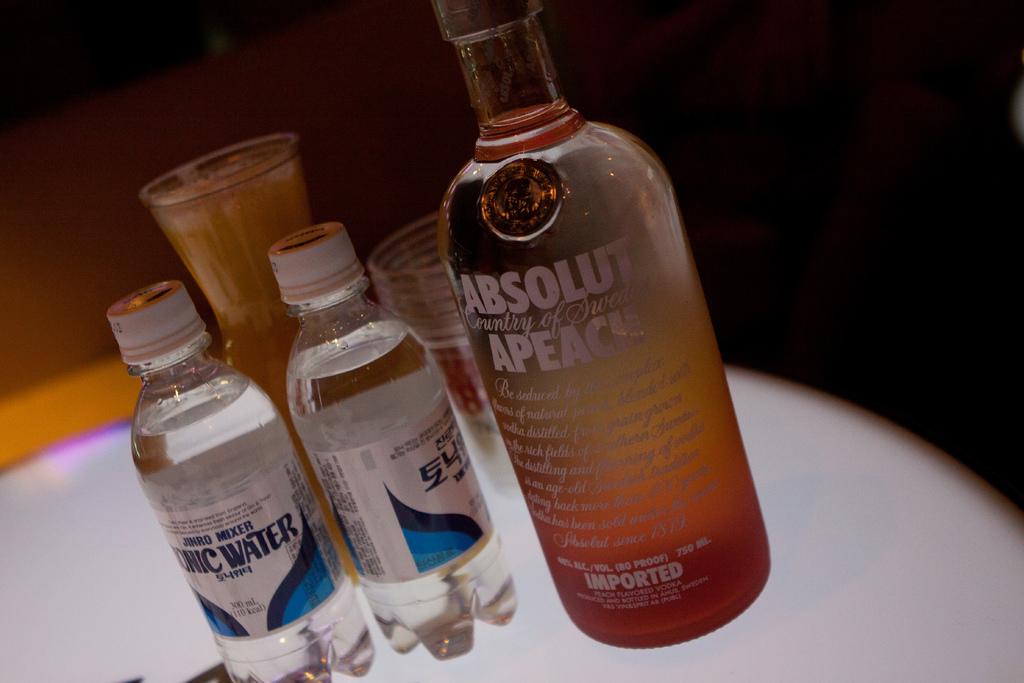What proof is the absolute vodka?
Ensure brevity in your answer.  80. 